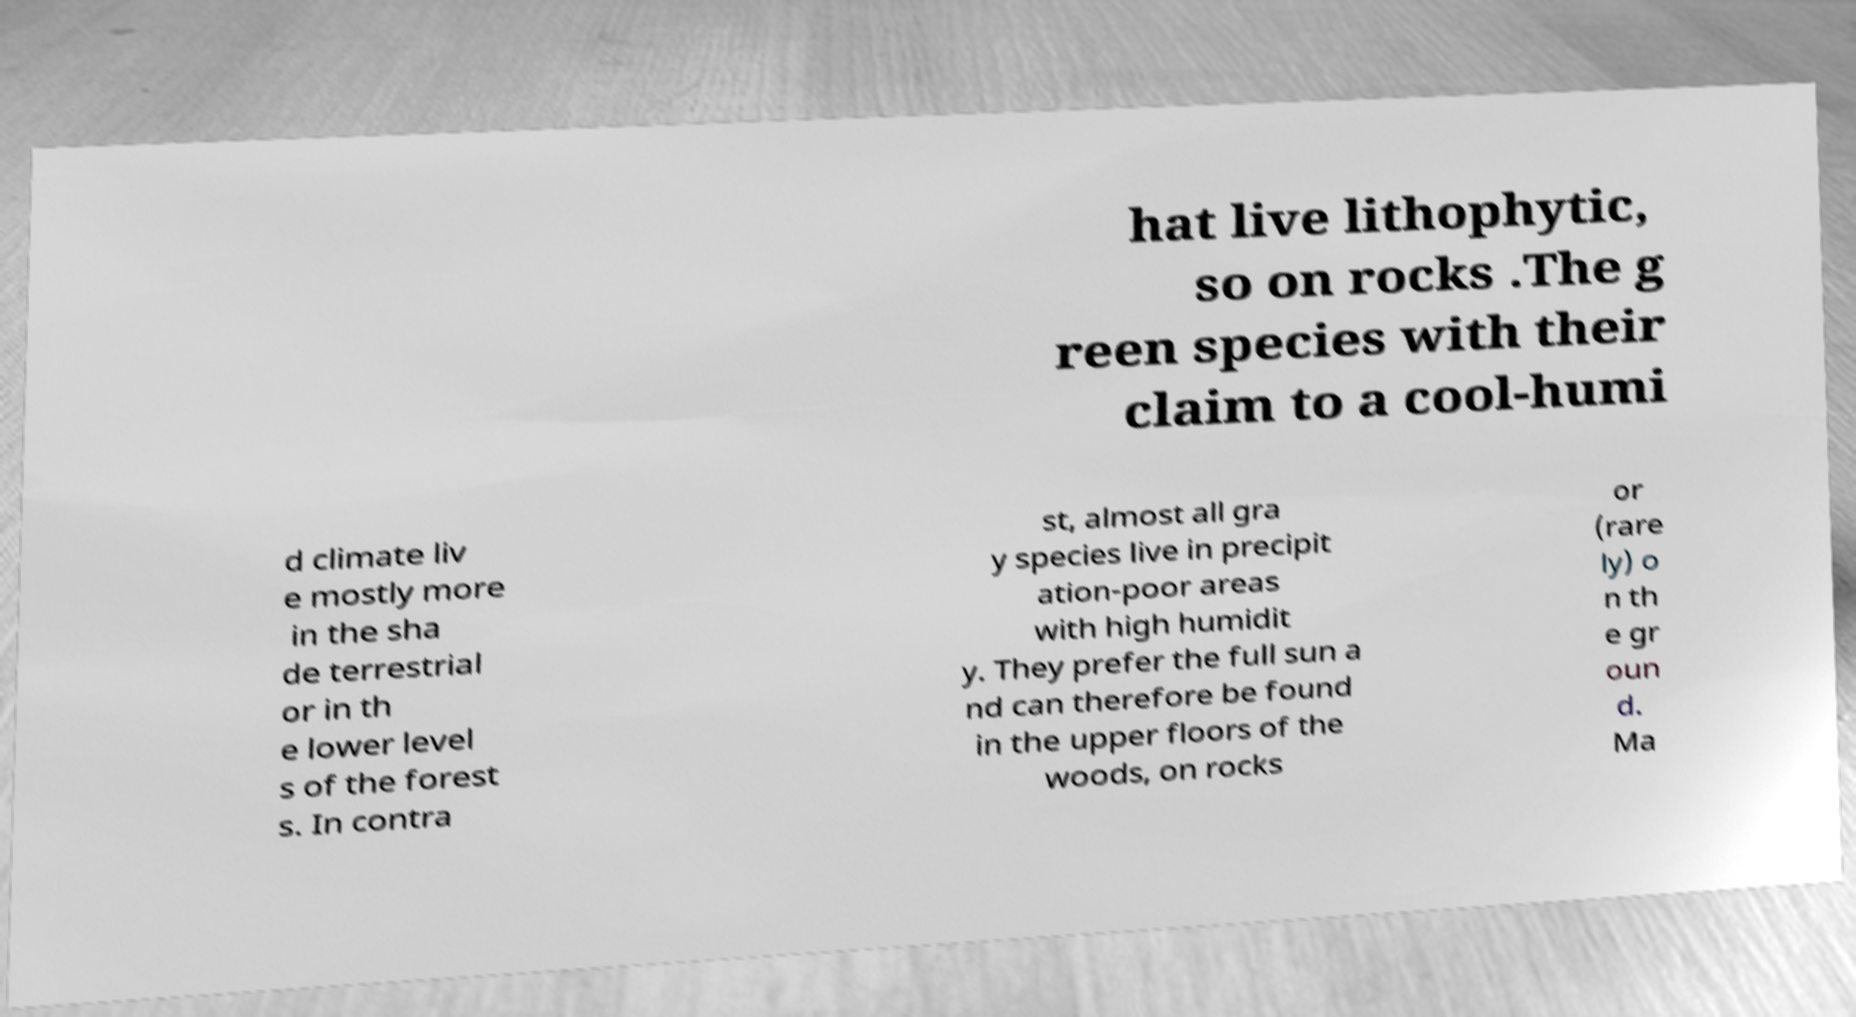What messages or text are displayed in this image? I need them in a readable, typed format. hat live lithophytic, so on rocks .The g reen species with their claim to a cool-humi d climate liv e mostly more in the sha de terrestrial or in th e lower level s of the forest s. In contra st, almost all gra y species live in precipit ation-poor areas with high humidit y. They prefer the full sun a nd can therefore be found in the upper floors of the woods, on rocks or (rare ly) o n th e gr oun d. Ma 